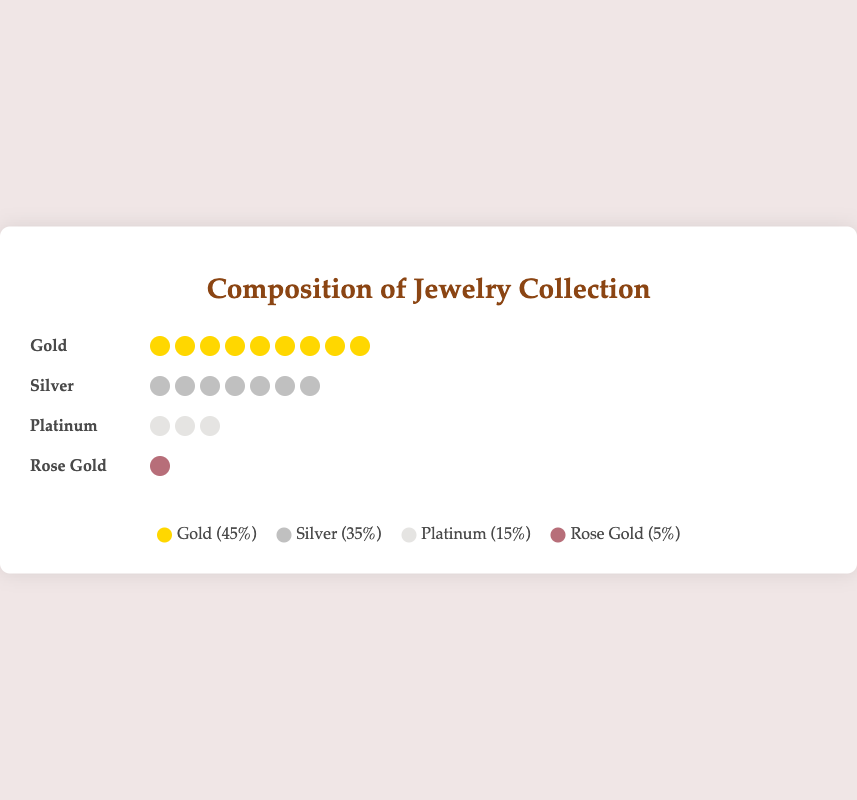What is the title of the plot? The title of the plot is usually displayed at the top center of the figure. In this case, the title is clearly written as "Composition of Jewelry Collection".
Answer: Composition of Jewelry Collection Which metal has the highest percentage of jewelry pieces? The figure presents different metals along with their respective icons and their percentages. Observing these percentages, Gold has the highest value with 45%.
Answer: Gold How many types of metals are represented in the plot? By counting the distinct entries or labels listed under the metal categories in the figure, there are four types of metals represented: Gold, Silver, Platinum, and Rose Gold.
Answer: Four What percentage of the jewelry collection is made up of precious metals (Gold, Silver, and Platinum combined)? Adding the percentages of Gold (45%), Silver (35%), and Platinum (15%) from the figure data: 45% + 35% + 15% = 95%.
Answer: 95% How many icons represent Silver in the plot? Each icon typically represents a certain count within the categories. For Silver, the plot shows a series of icons. Counting these icons, there are 7 icons for Silver.
Answer: 7 What fraction of the jewelry collection is Rose Gold in terms of percentage? The figure shows the percentage directly for Rose Gold. It is indicated as 5%.
Answer: 5% Compare the number of icons representing Platinum to those representing Rose Gold. The plot visually depicts 3 icons for Platinum and 1 icon for Rose Gold. Comparing them directly shows there are 2 more icons for Platinum.
Answer: Platinum has 2 more icons than Rose Gold What is the difference in percentage between Gold and Silver jewelry pieces? The percentage for Gold is 45% while for Silver it is 35%. Subtracting these two values, 45% - 35% = 10%.
Answer: 10% What is the combined count of Gold and Platinum jewelry pieces? Referring to the figure data, Gold has a count of 90 pieces and Platinum has 30 pieces. Adding these, 90 + 30 = 120 pieces.
Answer: 120 pieces Which metal has the lowest count of jewelry pieces? By examining the counts provided for each metal in the figure data, Rose Gold has the lowest count with 10 pieces.
Answer: Rose Gold 